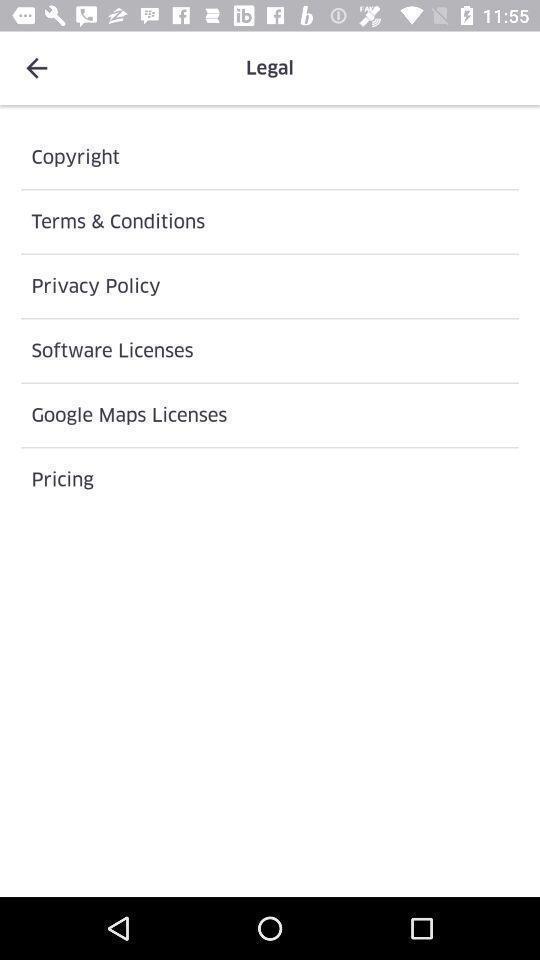Tell me what you see in this picture. Page displaying various options in a food app. 